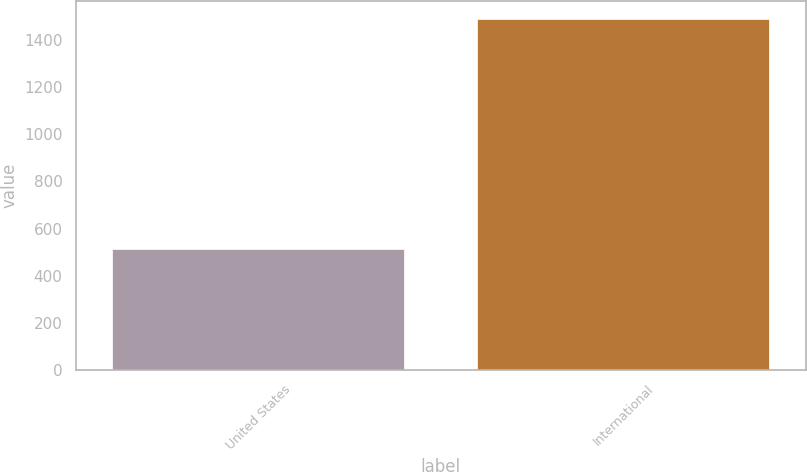Convert chart to OTSL. <chart><loc_0><loc_0><loc_500><loc_500><bar_chart><fcel>United States<fcel>International<nl><fcel>511.1<fcel>1491.3<nl></chart> 